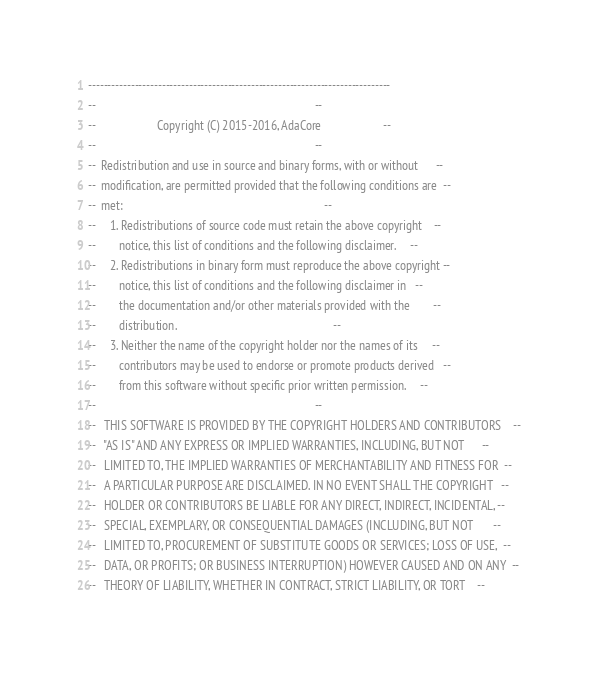Convert code to text. <code><loc_0><loc_0><loc_500><loc_500><_Ada_>------------------------------------------------------------------------------
--                                                                          --
--                     Copyright (C) 2015-2016, AdaCore                     --
--                                                                          --
--  Redistribution and use in source and binary forms, with or without      --
--  modification, are permitted provided that the following conditions are  --
--  met:                                                                    --
--     1. Redistributions of source code must retain the above copyright    --
--        notice, this list of conditions and the following disclaimer.     --
--     2. Redistributions in binary form must reproduce the above copyright --
--        notice, this list of conditions and the following disclaimer in   --
--        the documentation and/or other materials provided with the        --
--        distribution.                                                     --
--     3. Neither the name of the copyright holder nor the names of its     --
--        contributors may be used to endorse or promote products derived   --
--        from this software without specific prior written permission.     --
--                                                                          --
--   THIS SOFTWARE IS PROVIDED BY THE COPYRIGHT HOLDERS AND CONTRIBUTORS    --
--   "AS IS" AND ANY EXPRESS OR IMPLIED WARRANTIES, INCLUDING, BUT NOT      --
--   LIMITED TO, THE IMPLIED WARRANTIES OF MERCHANTABILITY AND FITNESS FOR  --
--   A PARTICULAR PURPOSE ARE DISCLAIMED. IN NO EVENT SHALL THE COPYRIGHT   --
--   HOLDER OR CONTRIBUTORS BE LIABLE FOR ANY DIRECT, INDIRECT, INCIDENTAL, --
--   SPECIAL, EXEMPLARY, OR CONSEQUENTIAL DAMAGES (INCLUDING, BUT NOT       --
--   LIMITED TO, PROCUREMENT OF SUBSTITUTE GOODS OR SERVICES; LOSS OF USE,  --
--   DATA, OR PROFITS; OR BUSINESS INTERRUPTION) HOWEVER CAUSED AND ON ANY  --
--   THEORY OF LIABILITY, WHETHER IN CONTRACT, STRICT LIABILITY, OR TORT    --</code> 